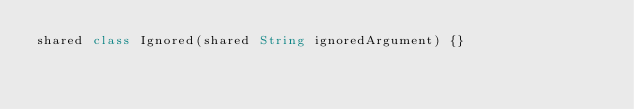<code> <loc_0><loc_0><loc_500><loc_500><_Ceylon_>shared class Ignored(shared String ignoredArgument) {}</code> 